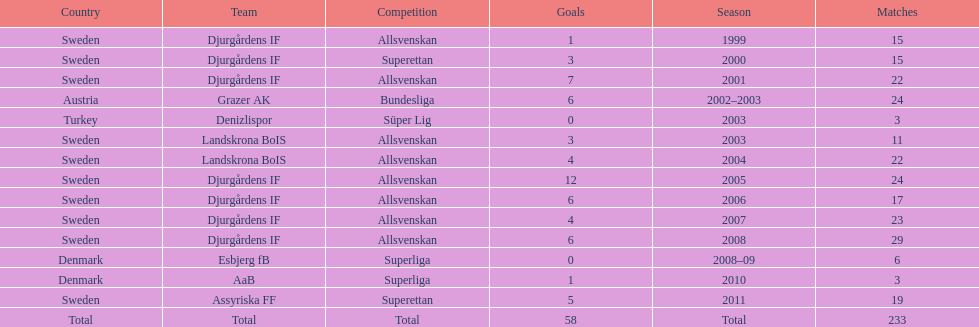What is the total number of matches? 233. 